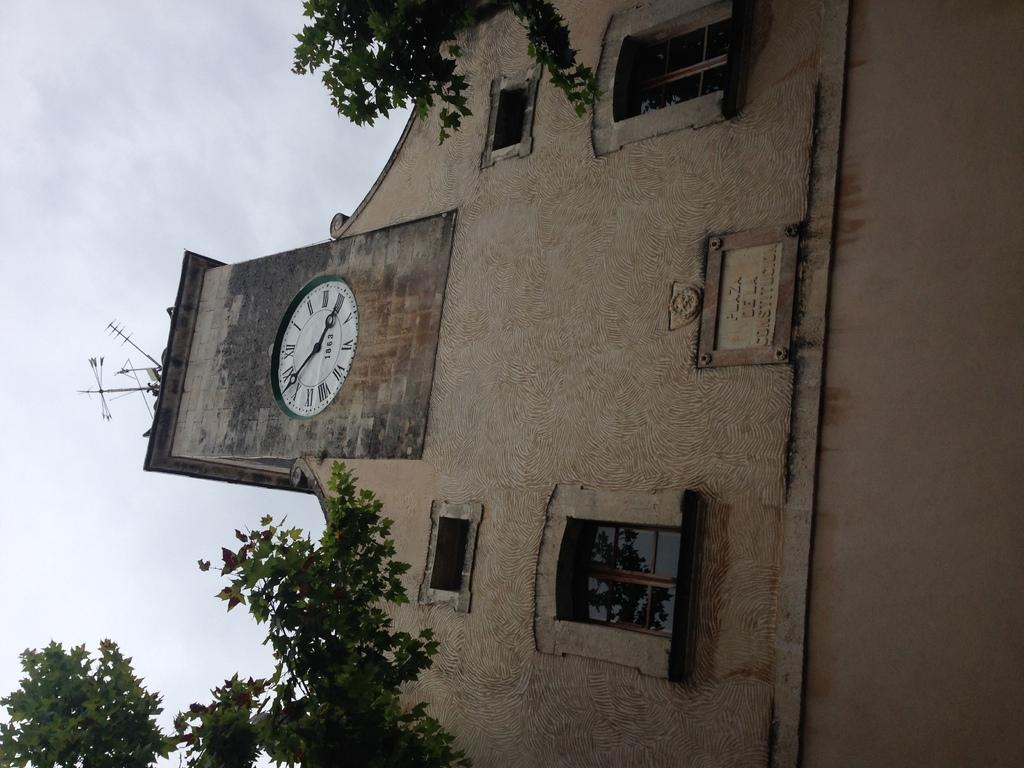<image>
Offer a succinct explanation of the picture presented. A plaque on the front of a clock tower wall says "Plaza de la Constitucion". 